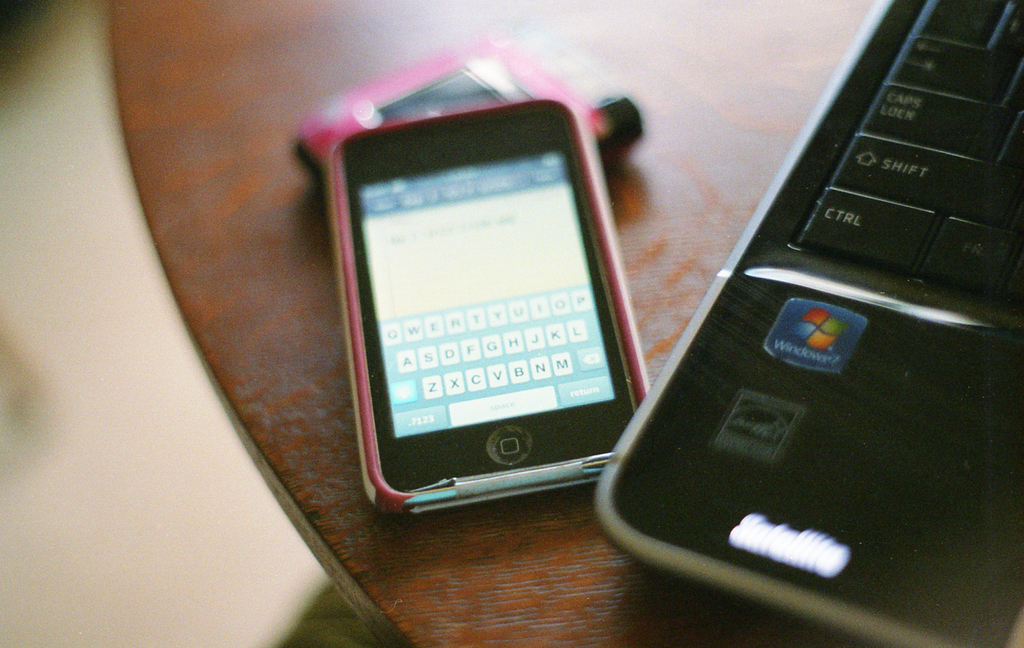What does the presence of the Windows logo on this laptop suggest about its age? The Windows logo displayed on the laptop is an older version, suggesting that this laptop could be from the early to mid-2000s. This style of logo was commonly used during that era, indicating the laptop's probable age and period of use. 